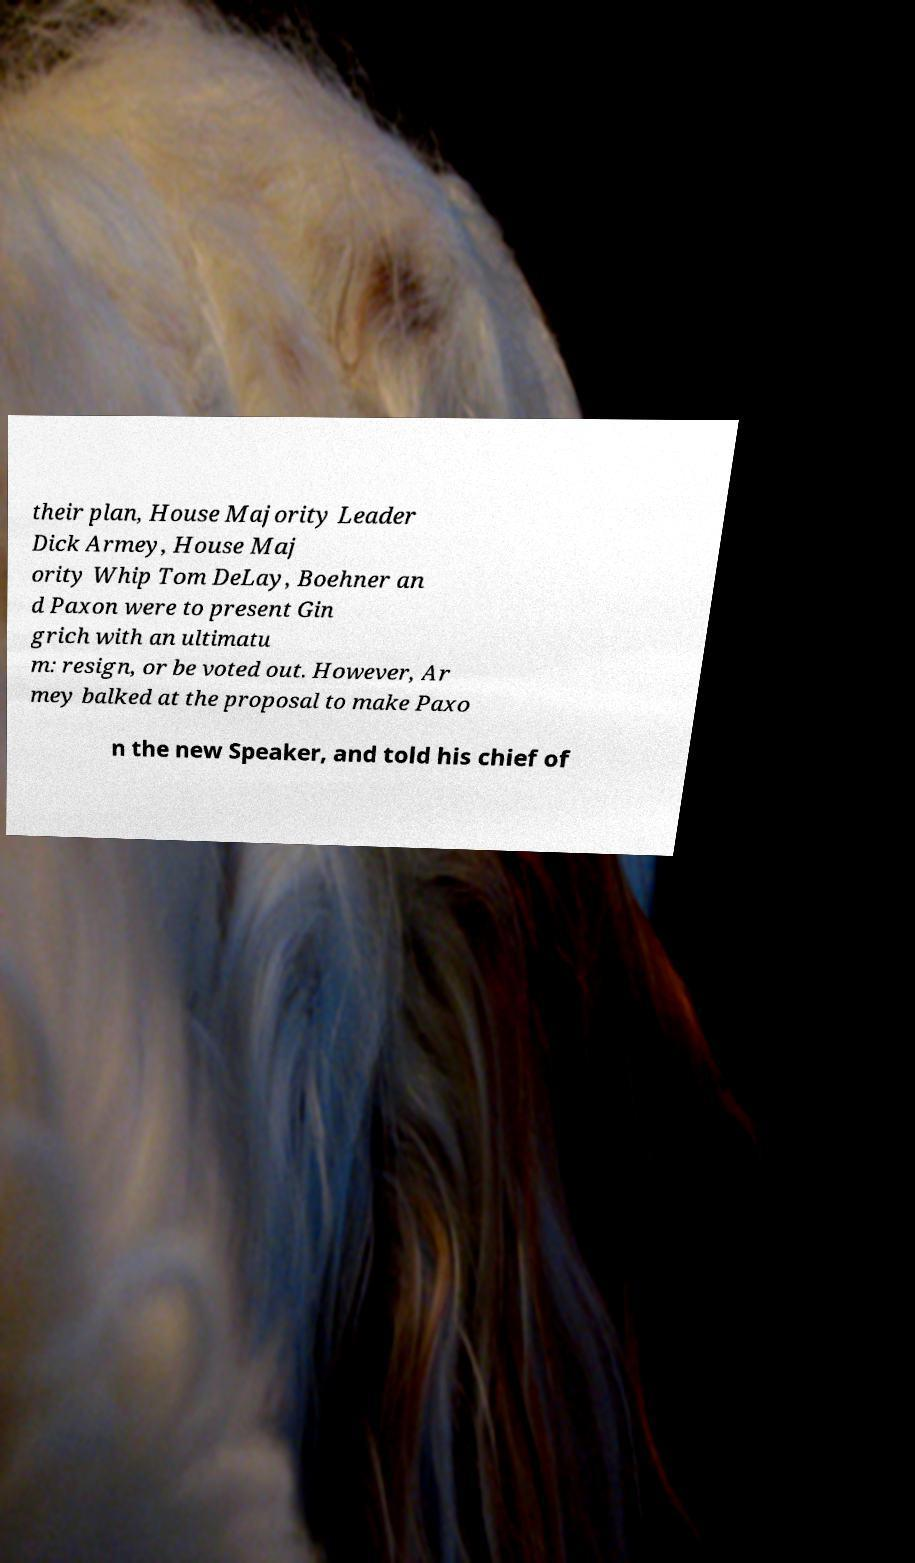Please read and relay the text visible in this image. What does it say? their plan, House Majority Leader Dick Armey, House Maj ority Whip Tom DeLay, Boehner an d Paxon were to present Gin grich with an ultimatu m: resign, or be voted out. However, Ar mey balked at the proposal to make Paxo n the new Speaker, and told his chief of 